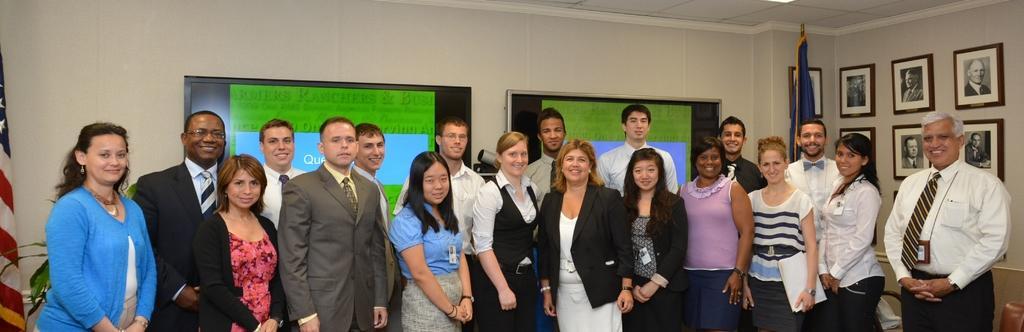How would you summarize this image in a sentence or two? In this given picture, We can see groups of people standing towards the left, We can see a couple of photo frames and a wall, a blue color flag, a black color board in middle, We can see a projector towards the left, We can see an artificial tree and flag. 